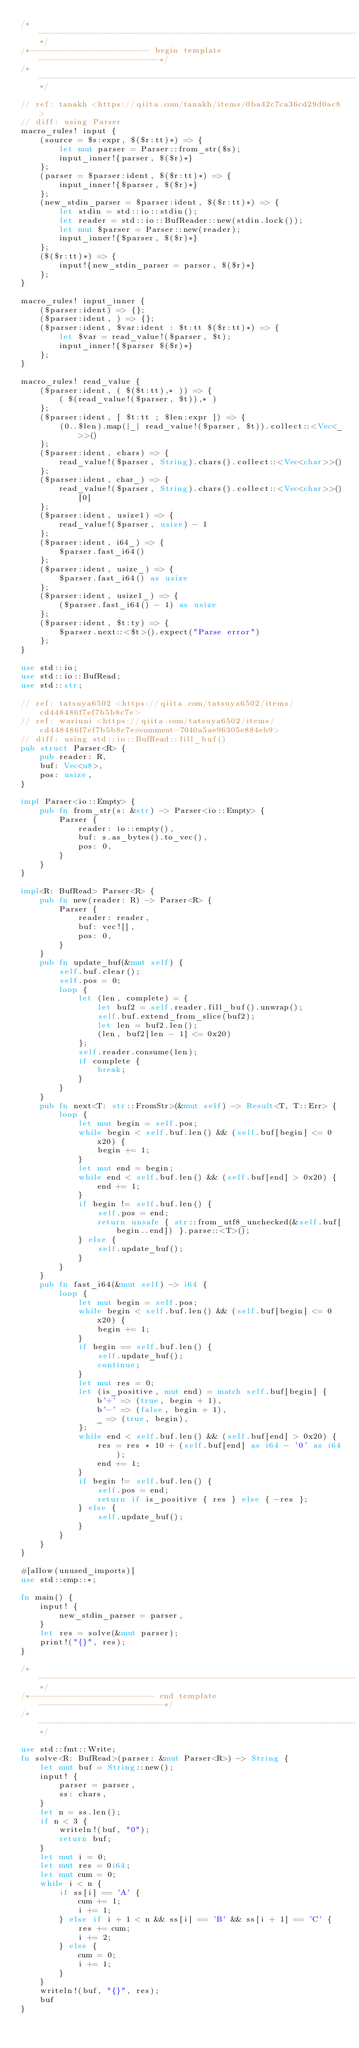Convert code to text. <code><loc_0><loc_0><loc_500><loc_500><_Rust_>/*------------------------------------------------------------------*/
/*------------------------- begin template -------------------------*/
/*------------------------------------------------------------------*/

// ref: tanakh <https://qiita.com/tanakh/items/0ba42c7ca36cd29d0ac8>
// diff: using Parser
macro_rules! input {
    (source = $s:expr, $($r:tt)*) => {
        let mut parser = Parser::from_str($s);
        input_inner!{parser, $($r)*}
    };
    (parser = $parser:ident, $($r:tt)*) => {
        input_inner!{$parser, $($r)*}
    };
    (new_stdin_parser = $parser:ident, $($r:tt)*) => {
        let stdin = std::io::stdin();
        let reader = std::io::BufReader::new(stdin.lock());
        let mut $parser = Parser::new(reader);
        input_inner!{$parser, $($r)*}
    };
    ($($r:tt)*) => {
        input!{new_stdin_parser = parser, $($r)*}
    };
}

macro_rules! input_inner {
    ($parser:ident) => {};
    ($parser:ident, ) => {};
    ($parser:ident, $var:ident : $t:tt $($r:tt)*) => {
        let $var = read_value!($parser, $t);
        input_inner!{$parser $($r)*}
    };
}

macro_rules! read_value {
    ($parser:ident, ( $($t:tt),* )) => {
        ( $(read_value!($parser, $t)),* )
    };
    ($parser:ident, [ $t:tt ; $len:expr ]) => {
        (0..$len).map(|_| read_value!($parser, $t)).collect::<Vec<_>>()
    };
    ($parser:ident, chars) => {
        read_value!($parser, String).chars().collect::<Vec<char>>()
    };
    ($parser:ident, char_) => {
        read_value!($parser, String).chars().collect::<Vec<char>>()[0]
    };
    ($parser:ident, usize1) => {
        read_value!($parser, usize) - 1
    };
    ($parser:ident, i64_) => {
        $parser.fast_i64()
    };
    ($parser:ident, usize_) => {
        $parser.fast_i64() as usize
    };
    ($parser:ident, usize1_) => {
        ($parser.fast_i64() - 1) as usize
    };
    ($parser:ident, $t:ty) => {
        $parser.next::<$t>().expect("Parse error")
    };
}

use std::io;
use std::io::BufRead;
use std::str;

// ref: tatsuya6502 <https://qiita.com/tatsuya6502/items/cd448486f7ef7b5b8c7e>
// ref: wariuni <https://qiita.com/tatsuya6502/items/cd448486f7ef7b5b8c7e#comment-7040a5ae96305e884eb9>
// diff: using std::io::BufRead::fill_buf()
pub struct Parser<R> {
    pub reader: R,
    buf: Vec<u8>,
    pos: usize,
}

impl Parser<io::Empty> {
    pub fn from_str(s: &str) -> Parser<io::Empty> {
        Parser {
            reader: io::empty(),
            buf: s.as_bytes().to_vec(),
            pos: 0,
        }
    }
}

impl<R: BufRead> Parser<R> {
    pub fn new(reader: R) -> Parser<R> {
        Parser {
            reader: reader,
            buf: vec![],
            pos: 0,
        }
    }
    pub fn update_buf(&mut self) {
        self.buf.clear();
        self.pos = 0;
        loop {
            let (len, complete) = {
                let buf2 = self.reader.fill_buf().unwrap();
                self.buf.extend_from_slice(buf2);
                let len = buf2.len();
                (len, buf2[len - 1] <= 0x20)
            };
            self.reader.consume(len);
            if complete {
                break;
            }
        }
    }
    pub fn next<T: str::FromStr>(&mut self) -> Result<T, T::Err> {
        loop {
            let mut begin = self.pos;
            while begin < self.buf.len() && (self.buf[begin] <= 0x20) {
                begin += 1;
            }
            let mut end = begin;
            while end < self.buf.len() && (self.buf[end] > 0x20) {
                end += 1;
            }
            if begin != self.buf.len() {
                self.pos = end;
                return unsafe { str::from_utf8_unchecked(&self.buf[begin..end]) }.parse::<T>();
            } else {
                self.update_buf();
            }
        }
    }
    pub fn fast_i64(&mut self) -> i64 {
        loop {
            let mut begin = self.pos;
            while begin < self.buf.len() && (self.buf[begin] <= 0x20) {
                begin += 1;
            }
            if begin == self.buf.len() {
                self.update_buf();
                continue;
            }
            let mut res = 0;
            let (is_positive, mut end) = match self.buf[begin] {
                b'+' => (true, begin + 1),
                b'-' => (false, begin + 1),
                _ => (true, begin),
            };
            while end < self.buf.len() && (self.buf[end] > 0x20) {
                res = res * 10 + (self.buf[end] as i64 - '0' as i64);
                end += 1;
            }
            if begin != self.buf.len() {
                self.pos = end;
                return if is_positive { res } else { -res };
            } else {
                self.update_buf();
            }
        }
    }
}

#[allow(unused_imports)]
use std::cmp::*;

fn main() {
    input! {
        new_stdin_parser = parser,
    }
    let res = solve(&mut parser);
    print!("{}", res);
}

/*------------------------------------------------------------------*/
/*-------------------------- end template --------------------------*/
/*------------------------------------------------------------------*/

use std::fmt::Write;
fn solve<R: BufRead>(parser: &mut Parser<R>) -> String {
    let mut buf = String::new();
    input! {
        parser = parser,
        ss: chars,
    }
    let n = ss.len();
    if n < 3 {
        writeln!(buf, "0");
        return buf;
    }
    let mut i = 0;
    let mut res = 0i64;
    let mut cum = 0;
    while i < n {
        if ss[i] == 'A' {
            cum += 1;
            i += 1;
        } else if i + 1 < n && ss[i] == 'B' && ss[i + 1] == 'C' {
            res += cum;
            i += 2;
        } else {
            cum = 0;
            i += 1;
        }
    }
    writeln!(buf, "{}", res);
    buf
}
</code> 